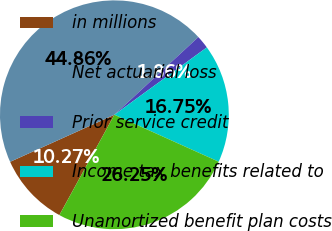Convert chart. <chart><loc_0><loc_0><loc_500><loc_500><pie_chart><fcel>in millions<fcel>Net actuarial loss<fcel>Prior service credit<fcel>Income tax benefits related to<fcel>Unamortized benefit plan costs<nl><fcel>10.27%<fcel>44.86%<fcel>1.86%<fcel>16.75%<fcel>26.25%<nl></chart> 